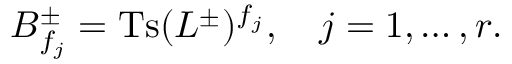<formula> <loc_0><loc_0><loc_500><loc_500>B _ { f _ { j } } ^ { \pm } = T s ( L ^ { \pm } ) ^ { f _ { j } } , \quad j = 1 , \dots , r .</formula> 